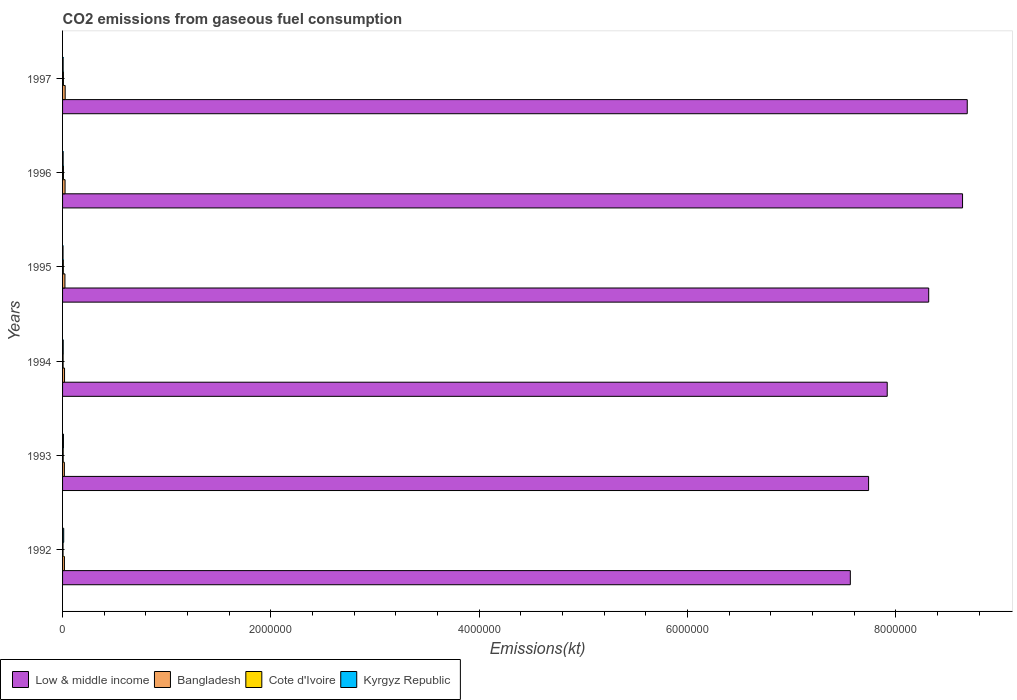How many groups of bars are there?
Keep it short and to the point. 6. Are the number of bars per tick equal to the number of legend labels?
Your response must be concise. Yes. How many bars are there on the 6th tick from the top?
Your answer should be very brief. 4. What is the label of the 4th group of bars from the top?
Your answer should be very brief. 1994. What is the amount of CO2 emitted in Bangladesh in 1992?
Your answer should be compact. 1.77e+04. Across all years, what is the maximum amount of CO2 emitted in Bangladesh?
Keep it short and to the point. 2.51e+04. Across all years, what is the minimum amount of CO2 emitted in Cote d'Ivoire?
Make the answer very short. 4624.09. In which year was the amount of CO2 emitted in Kyrgyz Republic maximum?
Ensure brevity in your answer.  1992. In which year was the amount of CO2 emitted in Kyrgyz Republic minimum?
Keep it short and to the point. 1995. What is the total amount of CO2 emitted in Low & middle income in the graph?
Make the answer very short. 4.89e+07. What is the difference between the amount of CO2 emitted in Bangladesh in 1992 and that in 1994?
Make the answer very short. -1221.11. What is the difference between the amount of CO2 emitted in Kyrgyz Republic in 1996 and the amount of CO2 emitted in Cote d'Ivoire in 1995?
Provide a succinct answer. -1543.81. What is the average amount of CO2 emitted in Cote d'Ivoire per year?
Keep it short and to the point. 6575.54. In the year 1997, what is the difference between the amount of CO2 emitted in Low & middle income and amount of CO2 emitted in Cote d'Ivoire?
Your response must be concise. 8.68e+06. In how many years, is the amount of CO2 emitted in Bangladesh greater than 5200000 kt?
Offer a terse response. 0. What is the ratio of the amount of CO2 emitted in Cote d'Ivoire in 1994 to that in 1996?
Your answer should be compact. 0.63. Is the amount of CO2 emitted in Bangladesh in 1993 less than that in 1996?
Your response must be concise. Yes. What is the difference between the highest and the second highest amount of CO2 emitted in Low & middle income?
Your answer should be very brief. 4.52e+04. What is the difference between the highest and the lowest amount of CO2 emitted in Kyrgyz Republic?
Offer a very short reply. 6424.58. What does the 1st bar from the top in 1993 represents?
Keep it short and to the point. Kyrgyz Republic. What does the 2nd bar from the bottom in 1992 represents?
Ensure brevity in your answer.  Bangladesh. What is the difference between two consecutive major ticks on the X-axis?
Provide a short and direct response. 2.00e+06. Does the graph contain any zero values?
Your answer should be compact. No. How are the legend labels stacked?
Provide a short and direct response. Horizontal. What is the title of the graph?
Provide a short and direct response. CO2 emissions from gaseous fuel consumption. Does "Netherlands" appear as one of the legend labels in the graph?
Your response must be concise. No. What is the label or title of the X-axis?
Provide a short and direct response. Emissions(kt). What is the label or title of the Y-axis?
Your answer should be compact. Years. What is the Emissions(kt) of Low & middle income in 1992?
Offer a terse response. 7.56e+06. What is the Emissions(kt) in Bangladesh in 1992?
Give a very brief answer. 1.77e+04. What is the Emissions(kt) in Cote d'Ivoire in 1992?
Keep it short and to the point. 4624.09. What is the Emissions(kt) in Kyrgyz Republic in 1992?
Give a very brief answer. 1.09e+04. What is the Emissions(kt) in Low & middle income in 1993?
Your response must be concise. 7.74e+06. What is the Emissions(kt) of Bangladesh in 1993?
Keep it short and to the point. 1.74e+04. What is the Emissions(kt) in Cote d'Ivoire in 1993?
Provide a succinct answer. 5892.87. What is the Emissions(kt) of Kyrgyz Republic in 1993?
Make the answer very short. 8305.75. What is the Emissions(kt) in Low & middle income in 1994?
Offer a very short reply. 7.92e+06. What is the Emissions(kt) of Bangladesh in 1994?
Provide a succinct answer. 1.90e+04. What is the Emissions(kt) of Cote d'Ivoire in 1994?
Make the answer very short. 5251.14. What is the Emissions(kt) in Kyrgyz Republic in 1994?
Your answer should be very brief. 6050.55. What is the Emissions(kt) in Low & middle income in 1995?
Provide a short and direct response. 8.31e+06. What is the Emissions(kt) of Bangladesh in 1995?
Your answer should be compact. 2.28e+04. What is the Emissions(kt) of Cote d'Ivoire in 1995?
Your answer should be very brief. 7132.31. What is the Emissions(kt) in Kyrgyz Republic in 1995?
Make the answer very short. 4437.07. What is the Emissions(kt) in Low & middle income in 1996?
Your answer should be compact. 8.64e+06. What is the Emissions(kt) in Bangladesh in 1996?
Make the answer very short. 2.40e+04. What is the Emissions(kt) in Cote d'Ivoire in 1996?
Give a very brief answer. 8379.09. What is the Emissions(kt) of Kyrgyz Republic in 1996?
Ensure brevity in your answer.  5588.51. What is the Emissions(kt) in Low & middle income in 1997?
Your answer should be very brief. 8.68e+06. What is the Emissions(kt) in Bangladesh in 1997?
Offer a very short reply. 2.51e+04. What is the Emissions(kt) in Cote d'Ivoire in 1997?
Offer a very short reply. 8173.74. What is the Emissions(kt) in Kyrgyz Republic in 1997?
Provide a succinct answer. 5482.16. Across all years, what is the maximum Emissions(kt) in Low & middle income?
Keep it short and to the point. 8.68e+06. Across all years, what is the maximum Emissions(kt) of Bangladesh?
Provide a short and direct response. 2.51e+04. Across all years, what is the maximum Emissions(kt) in Cote d'Ivoire?
Provide a short and direct response. 8379.09. Across all years, what is the maximum Emissions(kt) in Kyrgyz Republic?
Provide a succinct answer. 1.09e+04. Across all years, what is the minimum Emissions(kt) of Low & middle income?
Offer a very short reply. 7.56e+06. Across all years, what is the minimum Emissions(kt) of Bangladesh?
Offer a terse response. 1.74e+04. Across all years, what is the minimum Emissions(kt) of Cote d'Ivoire?
Keep it short and to the point. 4624.09. Across all years, what is the minimum Emissions(kt) of Kyrgyz Republic?
Your response must be concise. 4437.07. What is the total Emissions(kt) in Low & middle income in the graph?
Your response must be concise. 4.89e+07. What is the total Emissions(kt) of Bangladesh in the graph?
Provide a succinct answer. 1.26e+05. What is the total Emissions(kt) in Cote d'Ivoire in the graph?
Keep it short and to the point. 3.95e+04. What is the total Emissions(kt) in Kyrgyz Republic in the graph?
Your answer should be very brief. 4.07e+04. What is the difference between the Emissions(kt) in Low & middle income in 1992 and that in 1993?
Provide a succinct answer. -1.75e+05. What is the difference between the Emissions(kt) in Bangladesh in 1992 and that in 1993?
Your response must be concise. 341.03. What is the difference between the Emissions(kt) in Cote d'Ivoire in 1992 and that in 1993?
Provide a short and direct response. -1268.78. What is the difference between the Emissions(kt) of Kyrgyz Republic in 1992 and that in 1993?
Your answer should be very brief. 2555.9. What is the difference between the Emissions(kt) of Low & middle income in 1992 and that in 1994?
Offer a terse response. -3.54e+05. What is the difference between the Emissions(kt) in Bangladesh in 1992 and that in 1994?
Provide a succinct answer. -1221.11. What is the difference between the Emissions(kt) of Cote d'Ivoire in 1992 and that in 1994?
Your answer should be very brief. -627.06. What is the difference between the Emissions(kt) in Kyrgyz Republic in 1992 and that in 1994?
Offer a terse response. 4811.1. What is the difference between the Emissions(kt) of Low & middle income in 1992 and that in 1995?
Your response must be concise. -7.52e+05. What is the difference between the Emissions(kt) of Bangladesh in 1992 and that in 1995?
Provide a short and direct response. -5067.79. What is the difference between the Emissions(kt) in Cote d'Ivoire in 1992 and that in 1995?
Offer a terse response. -2508.23. What is the difference between the Emissions(kt) in Kyrgyz Republic in 1992 and that in 1995?
Your response must be concise. 6424.58. What is the difference between the Emissions(kt) in Low & middle income in 1992 and that in 1996?
Your response must be concise. -1.08e+06. What is the difference between the Emissions(kt) in Bangladesh in 1992 and that in 1996?
Your answer should be compact. -6281.57. What is the difference between the Emissions(kt) in Cote d'Ivoire in 1992 and that in 1996?
Your response must be concise. -3755.01. What is the difference between the Emissions(kt) of Kyrgyz Republic in 1992 and that in 1996?
Make the answer very short. 5273.15. What is the difference between the Emissions(kt) in Low & middle income in 1992 and that in 1997?
Give a very brief answer. -1.12e+06. What is the difference between the Emissions(kt) in Bangladesh in 1992 and that in 1997?
Offer a terse response. -7315.66. What is the difference between the Emissions(kt) in Cote d'Ivoire in 1992 and that in 1997?
Give a very brief answer. -3549.66. What is the difference between the Emissions(kt) of Kyrgyz Republic in 1992 and that in 1997?
Your answer should be compact. 5379.49. What is the difference between the Emissions(kt) in Low & middle income in 1993 and that in 1994?
Give a very brief answer. -1.79e+05. What is the difference between the Emissions(kt) in Bangladesh in 1993 and that in 1994?
Make the answer very short. -1562.14. What is the difference between the Emissions(kt) in Cote d'Ivoire in 1993 and that in 1994?
Your answer should be very brief. 641.73. What is the difference between the Emissions(kt) of Kyrgyz Republic in 1993 and that in 1994?
Your response must be concise. 2255.2. What is the difference between the Emissions(kt) in Low & middle income in 1993 and that in 1995?
Ensure brevity in your answer.  -5.77e+05. What is the difference between the Emissions(kt) in Bangladesh in 1993 and that in 1995?
Offer a terse response. -5408.82. What is the difference between the Emissions(kt) of Cote d'Ivoire in 1993 and that in 1995?
Your response must be concise. -1239.45. What is the difference between the Emissions(kt) of Kyrgyz Republic in 1993 and that in 1995?
Your answer should be compact. 3868.68. What is the difference between the Emissions(kt) of Low & middle income in 1993 and that in 1996?
Offer a terse response. -9.02e+05. What is the difference between the Emissions(kt) of Bangladesh in 1993 and that in 1996?
Provide a succinct answer. -6622.6. What is the difference between the Emissions(kt) in Cote d'Ivoire in 1993 and that in 1996?
Make the answer very short. -2486.23. What is the difference between the Emissions(kt) in Kyrgyz Republic in 1993 and that in 1996?
Your answer should be compact. 2717.25. What is the difference between the Emissions(kt) in Low & middle income in 1993 and that in 1997?
Your answer should be very brief. -9.47e+05. What is the difference between the Emissions(kt) in Bangladesh in 1993 and that in 1997?
Make the answer very short. -7656.7. What is the difference between the Emissions(kt) in Cote d'Ivoire in 1993 and that in 1997?
Offer a terse response. -2280.87. What is the difference between the Emissions(kt) of Kyrgyz Republic in 1993 and that in 1997?
Offer a very short reply. 2823.59. What is the difference between the Emissions(kt) in Low & middle income in 1994 and that in 1995?
Give a very brief answer. -3.98e+05. What is the difference between the Emissions(kt) of Bangladesh in 1994 and that in 1995?
Your answer should be compact. -3846.68. What is the difference between the Emissions(kt) of Cote d'Ivoire in 1994 and that in 1995?
Provide a succinct answer. -1881.17. What is the difference between the Emissions(kt) in Kyrgyz Republic in 1994 and that in 1995?
Your answer should be very brief. 1613.48. What is the difference between the Emissions(kt) in Low & middle income in 1994 and that in 1996?
Your answer should be very brief. -7.23e+05. What is the difference between the Emissions(kt) in Bangladesh in 1994 and that in 1996?
Your answer should be very brief. -5060.46. What is the difference between the Emissions(kt) of Cote d'Ivoire in 1994 and that in 1996?
Offer a very short reply. -3127.95. What is the difference between the Emissions(kt) of Kyrgyz Republic in 1994 and that in 1996?
Your response must be concise. 462.04. What is the difference between the Emissions(kt) in Low & middle income in 1994 and that in 1997?
Your response must be concise. -7.68e+05. What is the difference between the Emissions(kt) of Bangladesh in 1994 and that in 1997?
Keep it short and to the point. -6094.55. What is the difference between the Emissions(kt) in Cote d'Ivoire in 1994 and that in 1997?
Provide a short and direct response. -2922.6. What is the difference between the Emissions(kt) of Kyrgyz Republic in 1994 and that in 1997?
Your response must be concise. 568.38. What is the difference between the Emissions(kt) in Low & middle income in 1995 and that in 1996?
Offer a very short reply. -3.25e+05. What is the difference between the Emissions(kt) of Bangladesh in 1995 and that in 1996?
Your answer should be very brief. -1213.78. What is the difference between the Emissions(kt) in Cote d'Ivoire in 1995 and that in 1996?
Provide a succinct answer. -1246.78. What is the difference between the Emissions(kt) of Kyrgyz Republic in 1995 and that in 1996?
Keep it short and to the point. -1151.44. What is the difference between the Emissions(kt) of Low & middle income in 1995 and that in 1997?
Your answer should be compact. -3.70e+05. What is the difference between the Emissions(kt) of Bangladesh in 1995 and that in 1997?
Provide a succinct answer. -2247.87. What is the difference between the Emissions(kt) of Cote d'Ivoire in 1995 and that in 1997?
Make the answer very short. -1041.43. What is the difference between the Emissions(kt) of Kyrgyz Republic in 1995 and that in 1997?
Offer a very short reply. -1045.1. What is the difference between the Emissions(kt) of Low & middle income in 1996 and that in 1997?
Your response must be concise. -4.52e+04. What is the difference between the Emissions(kt) in Bangladesh in 1996 and that in 1997?
Offer a very short reply. -1034.09. What is the difference between the Emissions(kt) in Cote d'Ivoire in 1996 and that in 1997?
Your answer should be compact. 205.35. What is the difference between the Emissions(kt) in Kyrgyz Republic in 1996 and that in 1997?
Ensure brevity in your answer.  106.34. What is the difference between the Emissions(kt) of Low & middle income in 1992 and the Emissions(kt) of Bangladesh in 1993?
Provide a short and direct response. 7.54e+06. What is the difference between the Emissions(kt) in Low & middle income in 1992 and the Emissions(kt) in Cote d'Ivoire in 1993?
Your answer should be compact. 7.56e+06. What is the difference between the Emissions(kt) of Low & middle income in 1992 and the Emissions(kt) of Kyrgyz Republic in 1993?
Offer a terse response. 7.55e+06. What is the difference between the Emissions(kt) of Bangladesh in 1992 and the Emissions(kt) of Cote d'Ivoire in 1993?
Your answer should be very brief. 1.19e+04. What is the difference between the Emissions(kt) of Bangladesh in 1992 and the Emissions(kt) of Kyrgyz Republic in 1993?
Keep it short and to the point. 9442.52. What is the difference between the Emissions(kt) of Cote d'Ivoire in 1992 and the Emissions(kt) of Kyrgyz Republic in 1993?
Make the answer very short. -3681.67. What is the difference between the Emissions(kt) of Low & middle income in 1992 and the Emissions(kt) of Bangladesh in 1994?
Ensure brevity in your answer.  7.54e+06. What is the difference between the Emissions(kt) of Low & middle income in 1992 and the Emissions(kt) of Cote d'Ivoire in 1994?
Your response must be concise. 7.56e+06. What is the difference between the Emissions(kt) of Low & middle income in 1992 and the Emissions(kt) of Kyrgyz Republic in 1994?
Ensure brevity in your answer.  7.56e+06. What is the difference between the Emissions(kt) in Bangladesh in 1992 and the Emissions(kt) in Cote d'Ivoire in 1994?
Make the answer very short. 1.25e+04. What is the difference between the Emissions(kt) of Bangladesh in 1992 and the Emissions(kt) of Kyrgyz Republic in 1994?
Ensure brevity in your answer.  1.17e+04. What is the difference between the Emissions(kt) in Cote d'Ivoire in 1992 and the Emissions(kt) in Kyrgyz Republic in 1994?
Make the answer very short. -1426.46. What is the difference between the Emissions(kt) in Low & middle income in 1992 and the Emissions(kt) in Bangladesh in 1995?
Provide a short and direct response. 7.54e+06. What is the difference between the Emissions(kt) of Low & middle income in 1992 and the Emissions(kt) of Cote d'Ivoire in 1995?
Provide a succinct answer. 7.56e+06. What is the difference between the Emissions(kt) of Low & middle income in 1992 and the Emissions(kt) of Kyrgyz Republic in 1995?
Keep it short and to the point. 7.56e+06. What is the difference between the Emissions(kt) in Bangladesh in 1992 and the Emissions(kt) in Cote d'Ivoire in 1995?
Ensure brevity in your answer.  1.06e+04. What is the difference between the Emissions(kt) of Bangladesh in 1992 and the Emissions(kt) of Kyrgyz Republic in 1995?
Ensure brevity in your answer.  1.33e+04. What is the difference between the Emissions(kt) in Cote d'Ivoire in 1992 and the Emissions(kt) in Kyrgyz Republic in 1995?
Ensure brevity in your answer.  187.02. What is the difference between the Emissions(kt) in Low & middle income in 1992 and the Emissions(kt) in Bangladesh in 1996?
Provide a short and direct response. 7.54e+06. What is the difference between the Emissions(kt) of Low & middle income in 1992 and the Emissions(kt) of Cote d'Ivoire in 1996?
Ensure brevity in your answer.  7.55e+06. What is the difference between the Emissions(kt) in Low & middle income in 1992 and the Emissions(kt) in Kyrgyz Republic in 1996?
Make the answer very short. 7.56e+06. What is the difference between the Emissions(kt) of Bangladesh in 1992 and the Emissions(kt) of Cote d'Ivoire in 1996?
Provide a succinct answer. 9369.18. What is the difference between the Emissions(kt) in Bangladesh in 1992 and the Emissions(kt) in Kyrgyz Republic in 1996?
Your answer should be very brief. 1.22e+04. What is the difference between the Emissions(kt) in Cote d'Ivoire in 1992 and the Emissions(kt) in Kyrgyz Republic in 1996?
Your answer should be compact. -964.42. What is the difference between the Emissions(kt) of Low & middle income in 1992 and the Emissions(kt) of Bangladesh in 1997?
Ensure brevity in your answer.  7.54e+06. What is the difference between the Emissions(kt) in Low & middle income in 1992 and the Emissions(kt) in Cote d'Ivoire in 1997?
Offer a very short reply. 7.55e+06. What is the difference between the Emissions(kt) in Low & middle income in 1992 and the Emissions(kt) in Kyrgyz Republic in 1997?
Offer a terse response. 7.56e+06. What is the difference between the Emissions(kt) of Bangladesh in 1992 and the Emissions(kt) of Cote d'Ivoire in 1997?
Provide a short and direct response. 9574.54. What is the difference between the Emissions(kt) in Bangladesh in 1992 and the Emissions(kt) in Kyrgyz Republic in 1997?
Provide a succinct answer. 1.23e+04. What is the difference between the Emissions(kt) in Cote d'Ivoire in 1992 and the Emissions(kt) in Kyrgyz Republic in 1997?
Offer a terse response. -858.08. What is the difference between the Emissions(kt) of Low & middle income in 1993 and the Emissions(kt) of Bangladesh in 1994?
Your answer should be very brief. 7.72e+06. What is the difference between the Emissions(kt) of Low & middle income in 1993 and the Emissions(kt) of Cote d'Ivoire in 1994?
Your response must be concise. 7.73e+06. What is the difference between the Emissions(kt) of Low & middle income in 1993 and the Emissions(kt) of Kyrgyz Republic in 1994?
Provide a short and direct response. 7.73e+06. What is the difference between the Emissions(kt) in Bangladesh in 1993 and the Emissions(kt) in Cote d'Ivoire in 1994?
Offer a very short reply. 1.22e+04. What is the difference between the Emissions(kt) in Bangladesh in 1993 and the Emissions(kt) in Kyrgyz Republic in 1994?
Keep it short and to the point. 1.14e+04. What is the difference between the Emissions(kt) in Cote d'Ivoire in 1993 and the Emissions(kt) in Kyrgyz Republic in 1994?
Your answer should be compact. -157.68. What is the difference between the Emissions(kt) in Low & middle income in 1993 and the Emissions(kt) in Bangladesh in 1995?
Offer a very short reply. 7.71e+06. What is the difference between the Emissions(kt) of Low & middle income in 1993 and the Emissions(kt) of Cote d'Ivoire in 1995?
Make the answer very short. 7.73e+06. What is the difference between the Emissions(kt) in Low & middle income in 1993 and the Emissions(kt) in Kyrgyz Republic in 1995?
Ensure brevity in your answer.  7.73e+06. What is the difference between the Emissions(kt) of Bangladesh in 1993 and the Emissions(kt) of Cote d'Ivoire in 1995?
Offer a terse response. 1.03e+04. What is the difference between the Emissions(kt) of Bangladesh in 1993 and the Emissions(kt) of Kyrgyz Republic in 1995?
Your answer should be compact. 1.30e+04. What is the difference between the Emissions(kt) in Cote d'Ivoire in 1993 and the Emissions(kt) in Kyrgyz Republic in 1995?
Your response must be concise. 1455.8. What is the difference between the Emissions(kt) in Low & middle income in 1993 and the Emissions(kt) in Bangladesh in 1996?
Give a very brief answer. 7.71e+06. What is the difference between the Emissions(kt) of Low & middle income in 1993 and the Emissions(kt) of Cote d'Ivoire in 1996?
Keep it short and to the point. 7.73e+06. What is the difference between the Emissions(kt) of Low & middle income in 1993 and the Emissions(kt) of Kyrgyz Republic in 1996?
Your response must be concise. 7.73e+06. What is the difference between the Emissions(kt) of Bangladesh in 1993 and the Emissions(kt) of Cote d'Ivoire in 1996?
Keep it short and to the point. 9028.15. What is the difference between the Emissions(kt) of Bangladesh in 1993 and the Emissions(kt) of Kyrgyz Republic in 1996?
Offer a terse response. 1.18e+04. What is the difference between the Emissions(kt) of Cote d'Ivoire in 1993 and the Emissions(kt) of Kyrgyz Republic in 1996?
Provide a short and direct response. 304.36. What is the difference between the Emissions(kt) of Low & middle income in 1993 and the Emissions(kt) of Bangladesh in 1997?
Give a very brief answer. 7.71e+06. What is the difference between the Emissions(kt) of Low & middle income in 1993 and the Emissions(kt) of Cote d'Ivoire in 1997?
Give a very brief answer. 7.73e+06. What is the difference between the Emissions(kt) in Low & middle income in 1993 and the Emissions(kt) in Kyrgyz Republic in 1997?
Your answer should be very brief. 7.73e+06. What is the difference between the Emissions(kt) in Bangladesh in 1993 and the Emissions(kt) in Cote d'Ivoire in 1997?
Your answer should be very brief. 9233.51. What is the difference between the Emissions(kt) of Bangladesh in 1993 and the Emissions(kt) of Kyrgyz Republic in 1997?
Make the answer very short. 1.19e+04. What is the difference between the Emissions(kt) of Cote d'Ivoire in 1993 and the Emissions(kt) of Kyrgyz Republic in 1997?
Your answer should be very brief. 410.7. What is the difference between the Emissions(kt) of Low & middle income in 1994 and the Emissions(kt) of Bangladesh in 1995?
Your answer should be compact. 7.89e+06. What is the difference between the Emissions(kt) in Low & middle income in 1994 and the Emissions(kt) in Cote d'Ivoire in 1995?
Keep it short and to the point. 7.91e+06. What is the difference between the Emissions(kt) in Low & middle income in 1994 and the Emissions(kt) in Kyrgyz Republic in 1995?
Give a very brief answer. 7.91e+06. What is the difference between the Emissions(kt) in Bangladesh in 1994 and the Emissions(kt) in Cote d'Ivoire in 1995?
Ensure brevity in your answer.  1.18e+04. What is the difference between the Emissions(kt) of Bangladesh in 1994 and the Emissions(kt) of Kyrgyz Republic in 1995?
Your response must be concise. 1.45e+04. What is the difference between the Emissions(kt) in Cote d'Ivoire in 1994 and the Emissions(kt) in Kyrgyz Republic in 1995?
Give a very brief answer. 814.07. What is the difference between the Emissions(kt) in Low & middle income in 1994 and the Emissions(kt) in Bangladesh in 1996?
Provide a short and direct response. 7.89e+06. What is the difference between the Emissions(kt) in Low & middle income in 1994 and the Emissions(kt) in Cote d'Ivoire in 1996?
Give a very brief answer. 7.91e+06. What is the difference between the Emissions(kt) of Low & middle income in 1994 and the Emissions(kt) of Kyrgyz Republic in 1996?
Keep it short and to the point. 7.91e+06. What is the difference between the Emissions(kt) of Bangladesh in 1994 and the Emissions(kt) of Cote d'Ivoire in 1996?
Give a very brief answer. 1.06e+04. What is the difference between the Emissions(kt) in Bangladesh in 1994 and the Emissions(kt) in Kyrgyz Republic in 1996?
Your response must be concise. 1.34e+04. What is the difference between the Emissions(kt) of Cote d'Ivoire in 1994 and the Emissions(kt) of Kyrgyz Republic in 1996?
Offer a very short reply. -337.36. What is the difference between the Emissions(kt) in Low & middle income in 1994 and the Emissions(kt) in Bangladesh in 1997?
Offer a terse response. 7.89e+06. What is the difference between the Emissions(kt) in Low & middle income in 1994 and the Emissions(kt) in Cote d'Ivoire in 1997?
Make the answer very short. 7.91e+06. What is the difference between the Emissions(kt) of Low & middle income in 1994 and the Emissions(kt) of Kyrgyz Republic in 1997?
Your response must be concise. 7.91e+06. What is the difference between the Emissions(kt) of Bangladesh in 1994 and the Emissions(kt) of Cote d'Ivoire in 1997?
Your answer should be compact. 1.08e+04. What is the difference between the Emissions(kt) of Bangladesh in 1994 and the Emissions(kt) of Kyrgyz Republic in 1997?
Provide a short and direct response. 1.35e+04. What is the difference between the Emissions(kt) in Cote d'Ivoire in 1994 and the Emissions(kt) in Kyrgyz Republic in 1997?
Your answer should be very brief. -231.02. What is the difference between the Emissions(kt) of Low & middle income in 1995 and the Emissions(kt) of Bangladesh in 1996?
Make the answer very short. 8.29e+06. What is the difference between the Emissions(kt) of Low & middle income in 1995 and the Emissions(kt) of Cote d'Ivoire in 1996?
Your answer should be very brief. 8.31e+06. What is the difference between the Emissions(kt) of Low & middle income in 1995 and the Emissions(kt) of Kyrgyz Republic in 1996?
Your answer should be compact. 8.31e+06. What is the difference between the Emissions(kt) of Bangladesh in 1995 and the Emissions(kt) of Cote d'Ivoire in 1996?
Provide a short and direct response. 1.44e+04. What is the difference between the Emissions(kt) in Bangladesh in 1995 and the Emissions(kt) in Kyrgyz Republic in 1996?
Your answer should be very brief. 1.72e+04. What is the difference between the Emissions(kt) of Cote d'Ivoire in 1995 and the Emissions(kt) of Kyrgyz Republic in 1996?
Keep it short and to the point. 1543.81. What is the difference between the Emissions(kt) of Low & middle income in 1995 and the Emissions(kt) of Bangladesh in 1997?
Your answer should be very brief. 8.29e+06. What is the difference between the Emissions(kt) in Low & middle income in 1995 and the Emissions(kt) in Cote d'Ivoire in 1997?
Offer a very short reply. 8.31e+06. What is the difference between the Emissions(kt) of Low & middle income in 1995 and the Emissions(kt) of Kyrgyz Republic in 1997?
Ensure brevity in your answer.  8.31e+06. What is the difference between the Emissions(kt) of Bangladesh in 1995 and the Emissions(kt) of Cote d'Ivoire in 1997?
Your answer should be compact. 1.46e+04. What is the difference between the Emissions(kt) in Bangladesh in 1995 and the Emissions(kt) in Kyrgyz Republic in 1997?
Ensure brevity in your answer.  1.73e+04. What is the difference between the Emissions(kt) of Cote d'Ivoire in 1995 and the Emissions(kt) of Kyrgyz Republic in 1997?
Provide a succinct answer. 1650.15. What is the difference between the Emissions(kt) of Low & middle income in 1996 and the Emissions(kt) of Bangladesh in 1997?
Keep it short and to the point. 8.61e+06. What is the difference between the Emissions(kt) in Low & middle income in 1996 and the Emissions(kt) in Cote d'Ivoire in 1997?
Your response must be concise. 8.63e+06. What is the difference between the Emissions(kt) in Low & middle income in 1996 and the Emissions(kt) in Kyrgyz Republic in 1997?
Offer a very short reply. 8.63e+06. What is the difference between the Emissions(kt) of Bangladesh in 1996 and the Emissions(kt) of Cote d'Ivoire in 1997?
Your answer should be compact. 1.59e+04. What is the difference between the Emissions(kt) of Bangladesh in 1996 and the Emissions(kt) of Kyrgyz Republic in 1997?
Offer a terse response. 1.85e+04. What is the difference between the Emissions(kt) of Cote d'Ivoire in 1996 and the Emissions(kt) of Kyrgyz Republic in 1997?
Make the answer very short. 2896.93. What is the average Emissions(kt) in Low & middle income per year?
Make the answer very short. 8.14e+06. What is the average Emissions(kt) of Bangladesh per year?
Offer a terse response. 2.10e+04. What is the average Emissions(kt) in Cote d'Ivoire per year?
Provide a short and direct response. 6575.54. What is the average Emissions(kt) of Kyrgyz Republic per year?
Offer a very short reply. 6787.62. In the year 1992, what is the difference between the Emissions(kt) in Low & middle income and Emissions(kt) in Bangladesh?
Give a very brief answer. 7.54e+06. In the year 1992, what is the difference between the Emissions(kt) of Low & middle income and Emissions(kt) of Cote d'Ivoire?
Offer a very short reply. 7.56e+06. In the year 1992, what is the difference between the Emissions(kt) in Low & middle income and Emissions(kt) in Kyrgyz Republic?
Offer a terse response. 7.55e+06. In the year 1992, what is the difference between the Emissions(kt) of Bangladesh and Emissions(kt) of Cote d'Ivoire?
Keep it short and to the point. 1.31e+04. In the year 1992, what is the difference between the Emissions(kt) in Bangladesh and Emissions(kt) in Kyrgyz Republic?
Make the answer very short. 6886.63. In the year 1992, what is the difference between the Emissions(kt) in Cote d'Ivoire and Emissions(kt) in Kyrgyz Republic?
Your response must be concise. -6237.57. In the year 1993, what is the difference between the Emissions(kt) in Low & middle income and Emissions(kt) in Bangladesh?
Your response must be concise. 7.72e+06. In the year 1993, what is the difference between the Emissions(kt) in Low & middle income and Emissions(kt) in Cote d'Ivoire?
Your answer should be compact. 7.73e+06. In the year 1993, what is the difference between the Emissions(kt) in Low & middle income and Emissions(kt) in Kyrgyz Republic?
Offer a terse response. 7.73e+06. In the year 1993, what is the difference between the Emissions(kt) of Bangladesh and Emissions(kt) of Cote d'Ivoire?
Provide a short and direct response. 1.15e+04. In the year 1993, what is the difference between the Emissions(kt) in Bangladesh and Emissions(kt) in Kyrgyz Republic?
Your answer should be compact. 9101.49. In the year 1993, what is the difference between the Emissions(kt) of Cote d'Ivoire and Emissions(kt) of Kyrgyz Republic?
Ensure brevity in your answer.  -2412.89. In the year 1994, what is the difference between the Emissions(kt) in Low & middle income and Emissions(kt) in Bangladesh?
Provide a short and direct response. 7.90e+06. In the year 1994, what is the difference between the Emissions(kt) of Low & middle income and Emissions(kt) of Cote d'Ivoire?
Provide a short and direct response. 7.91e+06. In the year 1994, what is the difference between the Emissions(kt) in Low & middle income and Emissions(kt) in Kyrgyz Republic?
Offer a terse response. 7.91e+06. In the year 1994, what is the difference between the Emissions(kt) in Bangladesh and Emissions(kt) in Cote d'Ivoire?
Provide a succinct answer. 1.37e+04. In the year 1994, what is the difference between the Emissions(kt) of Bangladesh and Emissions(kt) of Kyrgyz Republic?
Ensure brevity in your answer.  1.29e+04. In the year 1994, what is the difference between the Emissions(kt) in Cote d'Ivoire and Emissions(kt) in Kyrgyz Republic?
Provide a short and direct response. -799.41. In the year 1995, what is the difference between the Emissions(kt) of Low & middle income and Emissions(kt) of Bangladesh?
Your response must be concise. 8.29e+06. In the year 1995, what is the difference between the Emissions(kt) of Low & middle income and Emissions(kt) of Cote d'Ivoire?
Your answer should be very brief. 8.31e+06. In the year 1995, what is the difference between the Emissions(kt) in Low & middle income and Emissions(kt) in Kyrgyz Republic?
Give a very brief answer. 8.31e+06. In the year 1995, what is the difference between the Emissions(kt) of Bangladesh and Emissions(kt) of Cote d'Ivoire?
Your response must be concise. 1.57e+04. In the year 1995, what is the difference between the Emissions(kt) of Bangladesh and Emissions(kt) of Kyrgyz Republic?
Offer a very short reply. 1.84e+04. In the year 1995, what is the difference between the Emissions(kt) in Cote d'Ivoire and Emissions(kt) in Kyrgyz Republic?
Your response must be concise. 2695.24. In the year 1996, what is the difference between the Emissions(kt) of Low & middle income and Emissions(kt) of Bangladesh?
Offer a very short reply. 8.62e+06. In the year 1996, what is the difference between the Emissions(kt) of Low & middle income and Emissions(kt) of Cote d'Ivoire?
Offer a very short reply. 8.63e+06. In the year 1996, what is the difference between the Emissions(kt) in Low & middle income and Emissions(kt) in Kyrgyz Republic?
Ensure brevity in your answer.  8.63e+06. In the year 1996, what is the difference between the Emissions(kt) in Bangladesh and Emissions(kt) in Cote d'Ivoire?
Offer a terse response. 1.57e+04. In the year 1996, what is the difference between the Emissions(kt) in Bangladesh and Emissions(kt) in Kyrgyz Republic?
Your response must be concise. 1.84e+04. In the year 1996, what is the difference between the Emissions(kt) in Cote d'Ivoire and Emissions(kt) in Kyrgyz Republic?
Offer a terse response. 2790.59. In the year 1997, what is the difference between the Emissions(kt) of Low & middle income and Emissions(kt) of Bangladesh?
Your response must be concise. 8.66e+06. In the year 1997, what is the difference between the Emissions(kt) in Low & middle income and Emissions(kt) in Cote d'Ivoire?
Your response must be concise. 8.68e+06. In the year 1997, what is the difference between the Emissions(kt) of Low & middle income and Emissions(kt) of Kyrgyz Republic?
Ensure brevity in your answer.  8.68e+06. In the year 1997, what is the difference between the Emissions(kt) of Bangladesh and Emissions(kt) of Cote d'Ivoire?
Your answer should be compact. 1.69e+04. In the year 1997, what is the difference between the Emissions(kt) in Bangladesh and Emissions(kt) in Kyrgyz Republic?
Provide a succinct answer. 1.96e+04. In the year 1997, what is the difference between the Emissions(kt) of Cote d'Ivoire and Emissions(kt) of Kyrgyz Republic?
Make the answer very short. 2691.58. What is the ratio of the Emissions(kt) in Low & middle income in 1992 to that in 1993?
Provide a short and direct response. 0.98. What is the ratio of the Emissions(kt) of Bangladesh in 1992 to that in 1993?
Your response must be concise. 1.02. What is the ratio of the Emissions(kt) of Cote d'Ivoire in 1992 to that in 1993?
Provide a short and direct response. 0.78. What is the ratio of the Emissions(kt) in Kyrgyz Republic in 1992 to that in 1993?
Make the answer very short. 1.31. What is the ratio of the Emissions(kt) in Low & middle income in 1992 to that in 1994?
Your response must be concise. 0.96. What is the ratio of the Emissions(kt) of Bangladesh in 1992 to that in 1994?
Offer a terse response. 0.94. What is the ratio of the Emissions(kt) of Cote d'Ivoire in 1992 to that in 1994?
Offer a terse response. 0.88. What is the ratio of the Emissions(kt) in Kyrgyz Republic in 1992 to that in 1994?
Your response must be concise. 1.8. What is the ratio of the Emissions(kt) of Low & middle income in 1992 to that in 1995?
Your answer should be compact. 0.91. What is the ratio of the Emissions(kt) in Bangladesh in 1992 to that in 1995?
Give a very brief answer. 0.78. What is the ratio of the Emissions(kt) of Cote d'Ivoire in 1992 to that in 1995?
Ensure brevity in your answer.  0.65. What is the ratio of the Emissions(kt) of Kyrgyz Republic in 1992 to that in 1995?
Your response must be concise. 2.45. What is the ratio of the Emissions(kt) in Low & middle income in 1992 to that in 1996?
Keep it short and to the point. 0.88. What is the ratio of the Emissions(kt) of Bangladesh in 1992 to that in 1996?
Your response must be concise. 0.74. What is the ratio of the Emissions(kt) in Cote d'Ivoire in 1992 to that in 1996?
Offer a very short reply. 0.55. What is the ratio of the Emissions(kt) of Kyrgyz Republic in 1992 to that in 1996?
Make the answer very short. 1.94. What is the ratio of the Emissions(kt) in Low & middle income in 1992 to that in 1997?
Offer a very short reply. 0.87. What is the ratio of the Emissions(kt) of Bangladesh in 1992 to that in 1997?
Your response must be concise. 0.71. What is the ratio of the Emissions(kt) of Cote d'Ivoire in 1992 to that in 1997?
Your response must be concise. 0.57. What is the ratio of the Emissions(kt) in Kyrgyz Republic in 1992 to that in 1997?
Your response must be concise. 1.98. What is the ratio of the Emissions(kt) of Low & middle income in 1993 to that in 1994?
Your answer should be compact. 0.98. What is the ratio of the Emissions(kt) of Bangladesh in 1993 to that in 1994?
Offer a terse response. 0.92. What is the ratio of the Emissions(kt) in Cote d'Ivoire in 1993 to that in 1994?
Give a very brief answer. 1.12. What is the ratio of the Emissions(kt) of Kyrgyz Republic in 1993 to that in 1994?
Your answer should be very brief. 1.37. What is the ratio of the Emissions(kt) in Low & middle income in 1993 to that in 1995?
Make the answer very short. 0.93. What is the ratio of the Emissions(kt) in Bangladesh in 1993 to that in 1995?
Your answer should be compact. 0.76. What is the ratio of the Emissions(kt) of Cote d'Ivoire in 1993 to that in 1995?
Offer a very short reply. 0.83. What is the ratio of the Emissions(kt) of Kyrgyz Republic in 1993 to that in 1995?
Your response must be concise. 1.87. What is the ratio of the Emissions(kt) in Low & middle income in 1993 to that in 1996?
Provide a short and direct response. 0.9. What is the ratio of the Emissions(kt) of Bangladesh in 1993 to that in 1996?
Provide a short and direct response. 0.72. What is the ratio of the Emissions(kt) in Cote d'Ivoire in 1993 to that in 1996?
Offer a terse response. 0.7. What is the ratio of the Emissions(kt) of Kyrgyz Republic in 1993 to that in 1996?
Give a very brief answer. 1.49. What is the ratio of the Emissions(kt) in Low & middle income in 1993 to that in 1997?
Provide a succinct answer. 0.89. What is the ratio of the Emissions(kt) of Bangladesh in 1993 to that in 1997?
Your answer should be very brief. 0.69. What is the ratio of the Emissions(kt) of Cote d'Ivoire in 1993 to that in 1997?
Provide a succinct answer. 0.72. What is the ratio of the Emissions(kt) of Kyrgyz Republic in 1993 to that in 1997?
Your answer should be very brief. 1.52. What is the ratio of the Emissions(kt) in Low & middle income in 1994 to that in 1995?
Your answer should be very brief. 0.95. What is the ratio of the Emissions(kt) in Bangladesh in 1994 to that in 1995?
Offer a very short reply. 0.83. What is the ratio of the Emissions(kt) of Cote d'Ivoire in 1994 to that in 1995?
Offer a terse response. 0.74. What is the ratio of the Emissions(kt) of Kyrgyz Republic in 1994 to that in 1995?
Your response must be concise. 1.36. What is the ratio of the Emissions(kt) in Low & middle income in 1994 to that in 1996?
Provide a short and direct response. 0.92. What is the ratio of the Emissions(kt) in Bangladesh in 1994 to that in 1996?
Give a very brief answer. 0.79. What is the ratio of the Emissions(kt) in Cote d'Ivoire in 1994 to that in 1996?
Your answer should be very brief. 0.63. What is the ratio of the Emissions(kt) of Kyrgyz Republic in 1994 to that in 1996?
Give a very brief answer. 1.08. What is the ratio of the Emissions(kt) in Low & middle income in 1994 to that in 1997?
Keep it short and to the point. 0.91. What is the ratio of the Emissions(kt) in Bangladesh in 1994 to that in 1997?
Your answer should be very brief. 0.76. What is the ratio of the Emissions(kt) of Cote d'Ivoire in 1994 to that in 1997?
Keep it short and to the point. 0.64. What is the ratio of the Emissions(kt) of Kyrgyz Republic in 1994 to that in 1997?
Give a very brief answer. 1.1. What is the ratio of the Emissions(kt) of Low & middle income in 1995 to that in 1996?
Offer a very short reply. 0.96. What is the ratio of the Emissions(kt) in Bangladesh in 1995 to that in 1996?
Give a very brief answer. 0.95. What is the ratio of the Emissions(kt) in Cote d'Ivoire in 1995 to that in 1996?
Offer a terse response. 0.85. What is the ratio of the Emissions(kt) in Kyrgyz Republic in 1995 to that in 1996?
Make the answer very short. 0.79. What is the ratio of the Emissions(kt) of Low & middle income in 1995 to that in 1997?
Give a very brief answer. 0.96. What is the ratio of the Emissions(kt) of Bangladesh in 1995 to that in 1997?
Provide a short and direct response. 0.91. What is the ratio of the Emissions(kt) of Cote d'Ivoire in 1995 to that in 1997?
Offer a very short reply. 0.87. What is the ratio of the Emissions(kt) in Kyrgyz Republic in 1995 to that in 1997?
Your answer should be compact. 0.81. What is the ratio of the Emissions(kt) in Bangladesh in 1996 to that in 1997?
Provide a short and direct response. 0.96. What is the ratio of the Emissions(kt) of Cote d'Ivoire in 1996 to that in 1997?
Your answer should be very brief. 1.03. What is the ratio of the Emissions(kt) in Kyrgyz Republic in 1996 to that in 1997?
Provide a succinct answer. 1.02. What is the difference between the highest and the second highest Emissions(kt) of Low & middle income?
Provide a succinct answer. 4.52e+04. What is the difference between the highest and the second highest Emissions(kt) of Bangladesh?
Keep it short and to the point. 1034.09. What is the difference between the highest and the second highest Emissions(kt) in Cote d'Ivoire?
Offer a very short reply. 205.35. What is the difference between the highest and the second highest Emissions(kt) of Kyrgyz Republic?
Provide a short and direct response. 2555.9. What is the difference between the highest and the lowest Emissions(kt) in Low & middle income?
Offer a very short reply. 1.12e+06. What is the difference between the highest and the lowest Emissions(kt) in Bangladesh?
Offer a terse response. 7656.7. What is the difference between the highest and the lowest Emissions(kt) in Cote d'Ivoire?
Make the answer very short. 3755.01. What is the difference between the highest and the lowest Emissions(kt) in Kyrgyz Republic?
Provide a succinct answer. 6424.58. 